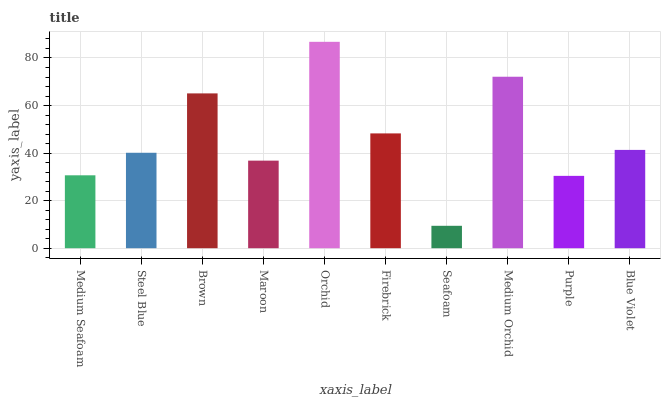Is Seafoam the minimum?
Answer yes or no. Yes. Is Orchid the maximum?
Answer yes or no. Yes. Is Steel Blue the minimum?
Answer yes or no. No. Is Steel Blue the maximum?
Answer yes or no. No. Is Steel Blue greater than Medium Seafoam?
Answer yes or no. Yes. Is Medium Seafoam less than Steel Blue?
Answer yes or no. Yes. Is Medium Seafoam greater than Steel Blue?
Answer yes or no. No. Is Steel Blue less than Medium Seafoam?
Answer yes or no. No. Is Blue Violet the high median?
Answer yes or no. Yes. Is Steel Blue the low median?
Answer yes or no. Yes. Is Seafoam the high median?
Answer yes or no. No. Is Maroon the low median?
Answer yes or no. No. 